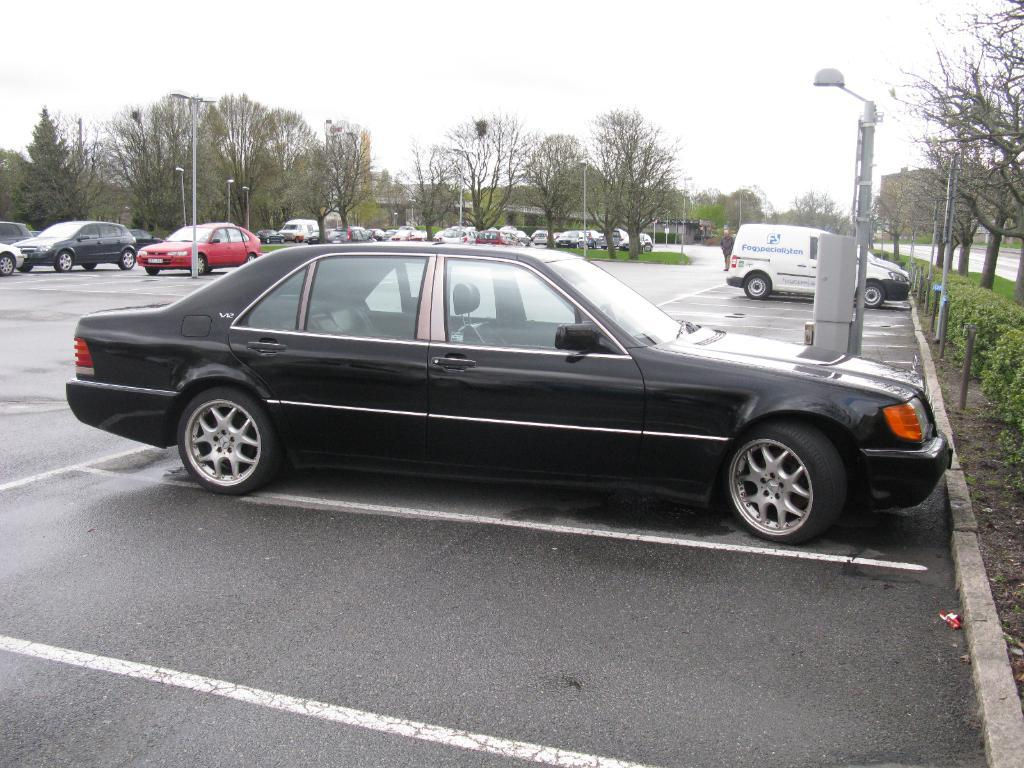What types of objects are present in the image? There are vehicles in the image. Can you describe one of the vehicles? One of the vehicles is black. What can be seen in the background of the image? There are trees and light poles in the background of the image. What is the color of the sky in the image? The sky appears to be white in color. How many shoes are hanging from the trees in the image? There are no shoes hanging from the trees in the image; only trees and light poles are present in the background. 